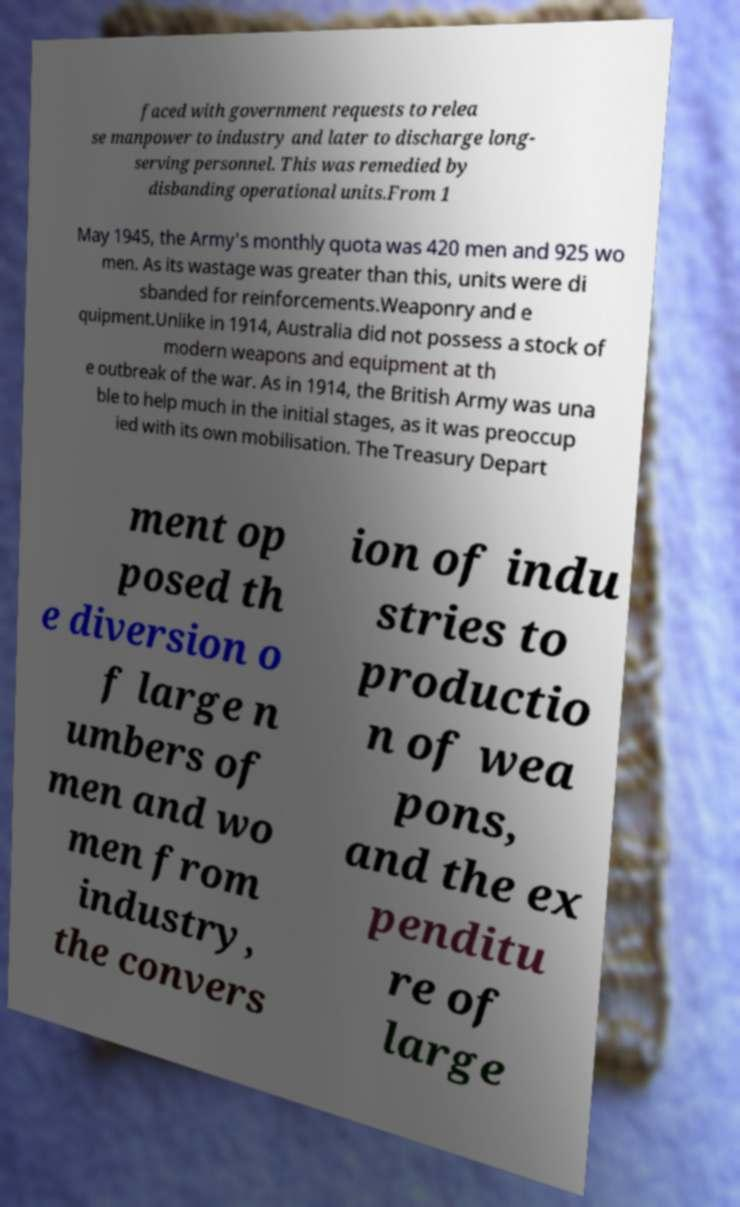Could you extract and type out the text from this image? faced with government requests to relea se manpower to industry and later to discharge long- serving personnel. This was remedied by disbanding operational units.From 1 May 1945, the Army's monthly quota was 420 men and 925 wo men. As its wastage was greater than this, units were di sbanded for reinforcements.Weaponry and e quipment.Unlike in 1914, Australia did not possess a stock of modern weapons and equipment at th e outbreak of the war. As in 1914, the British Army was una ble to help much in the initial stages, as it was preoccup ied with its own mobilisation. The Treasury Depart ment op posed th e diversion o f large n umbers of men and wo men from industry, the convers ion of indu stries to productio n of wea pons, and the ex penditu re of large 